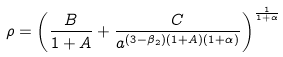<formula> <loc_0><loc_0><loc_500><loc_500>\rho = \left ( \frac { B } { 1 + A } + \frac { C } { a ^ { ( 3 - \beta _ { 2 } ) ( 1 + A ) ( 1 + \alpha ) } } \right ) ^ { \frac { 1 } { 1 + \alpha } }</formula> 